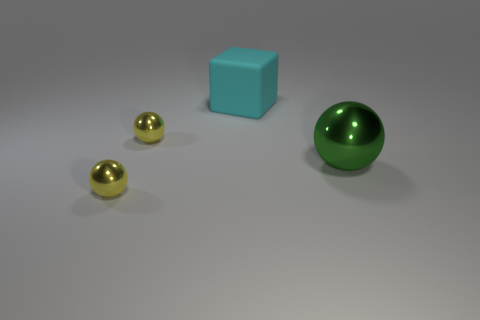Do the large thing that is behind the big green shiny object and the small thing in front of the green ball have the same shape?
Make the answer very short. No. There is a green metallic thing; how many large cyan matte blocks are on the left side of it?
Your response must be concise. 1. Do the object on the right side of the rubber block and the cyan block have the same material?
Your answer should be very brief. No. What shape is the large cyan thing?
Your answer should be very brief. Cube. What number of objects are either green things or rubber blocks?
Offer a very short reply. 2. There is a large object that is behind the green metal sphere; is it the same color as the metal thing to the right of the big cyan cube?
Keep it short and to the point. No. What number of other things are there of the same shape as the green object?
Your answer should be compact. 2. Are any green objects visible?
Keep it short and to the point. Yes. What number of objects are either large balls or tiny metal balls that are behind the big green thing?
Make the answer very short. 2. Are there the same number of large cubes and yellow shiny things?
Keep it short and to the point. No. 